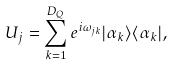Convert formula to latex. <formula><loc_0><loc_0><loc_500><loc_500>U _ { j } = \sum _ { k = 1 } ^ { D _ { Q } } e ^ { i { \omega } _ { j k } } | { \alpha } _ { k } { \rangle } { \langle } { \alpha } _ { k } | ,</formula> 